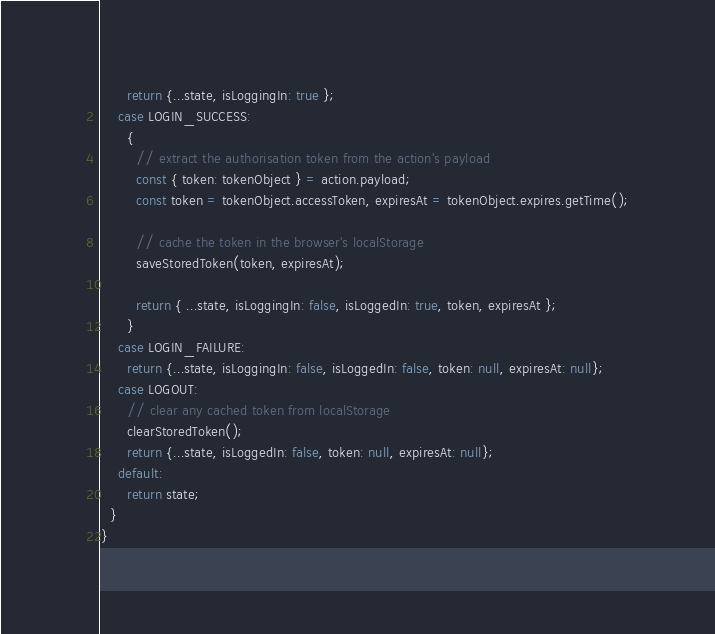Convert code to text. <code><loc_0><loc_0><loc_500><loc_500><_JavaScript_>      return {...state, isLoggingIn: true };
    case LOGIN_SUCCESS:
      {
        // extract the authorisation token from the action's payload
        const { token: tokenObject } = action.payload;
        const token = tokenObject.accessToken, expiresAt = tokenObject.expires.getTime();

        // cache the token in the browser's localStorage
        saveStoredToken(token, expiresAt);

        return { ...state, isLoggingIn: false, isLoggedIn: true, token, expiresAt };
      }
    case LOGIN_FAILURE:
      return {...state, isLoggingIn: false, isLoggedIn: false, token: null, expiresAt: null};
    case LOGOUT:
      // clear any cached token from localStorage
      clearStoredToken();
      return {...state, isLoggedIn: false, token: null, expiresAt: null};
    default:
      return state;
  }
}
</code> 